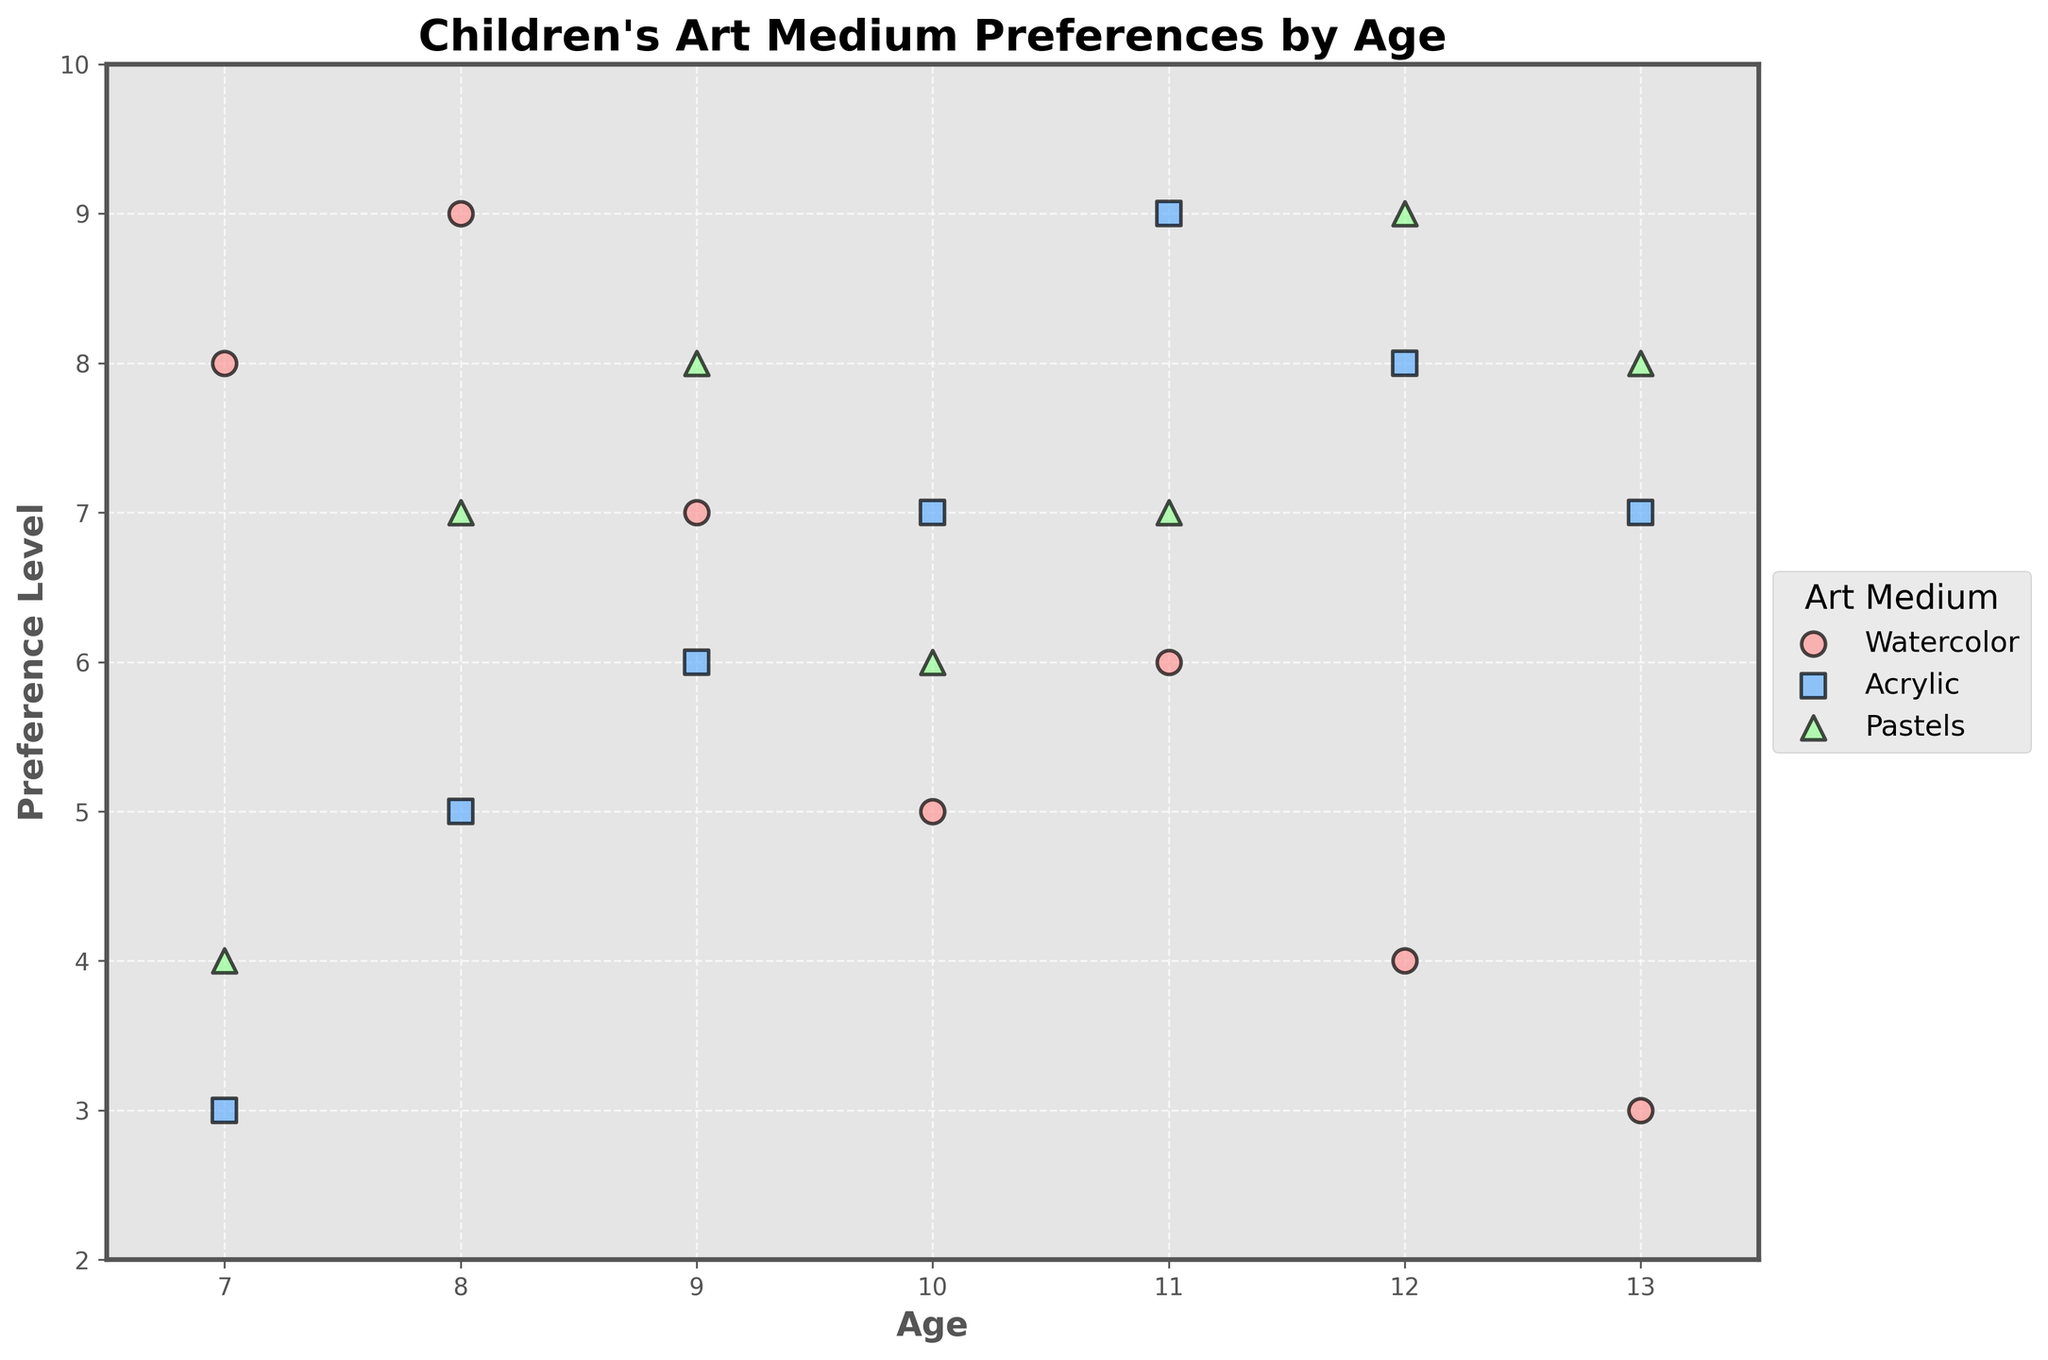What's the title of the plot? The title is located at the top center of the plot. Reading it will provide the name given to the visual representation.
Answer: Children's Art Medium Preferences by Age What is the color used to represent Watercolor? The points for different art mediums are represented in different colors. Watercolor is shown in light red.
Answer: light red How many different age groups are shown in the plot? The x-axis shows the age groups from 7 to 13, inclusive. Calculating the number of distinct ages gives us the number of groups.
Answer: 7 Which art medium shows a preference level of 9 for age 12? Locate the age of 12 on the x-axis, then find the preference level of 9 on the y-axis intersecting this age group. The data point should be marked and colored according to its respective art medium.
Answer: Pastels What is the average preference level for Acrylic across all age groups? First, collect the preference levels for Acrylic (3, 5, 6, 7, 9, 8, 7). Next, sum these values and divide by the number of data points to find the average: (3 + 5 + 6 + 7 + 9 + 8 + 7) / 7 = 6.42857.
Answer: 6.43 Which art medium has the highest recorded preference level, and what is the value? Identify the maximum y-value among all the represented data points. Check the corresponding art medium color and marker shape: the highest value is 9, shared by Watercolor at age 8, Acrylic at age 11, and Pastels at ages 12 and 13.
Answer: Watercolor, Acrylic, Pastels with 9 For age 9, which art medium has the lowest preference level? Look at the data points plotted for age 9 and compare the y-values. The lowest y-value corresponds to the lowest preference level.
Answer: Watercolor For age 7, what is the difference in preference levels between Watercolor and Acrylic? Identify the preference levels for both Watercolor and Acrylic at age 7: Watercolor is 8, Acrylic is 3. Subtract the lower value from the higher value to find the difference: 8 - 3 = 5.
Answer: 5 Which art medium shows the least variation in preference levels across all ages? The variation can be visually estimated by looking at the spread of data points for each art medium. The one with points clustering more tightly exhibits the least variation. In this case, Acrylic seems to show the least variation.
Answer: Acrylic What is the total number of data points in the scatter plot? The data provides three preference levels for each age group from 7 to 13. There are 7 age groups; thus, the total number of data points is 7 ages * 3 data points per age = 21.
Answer: 21 